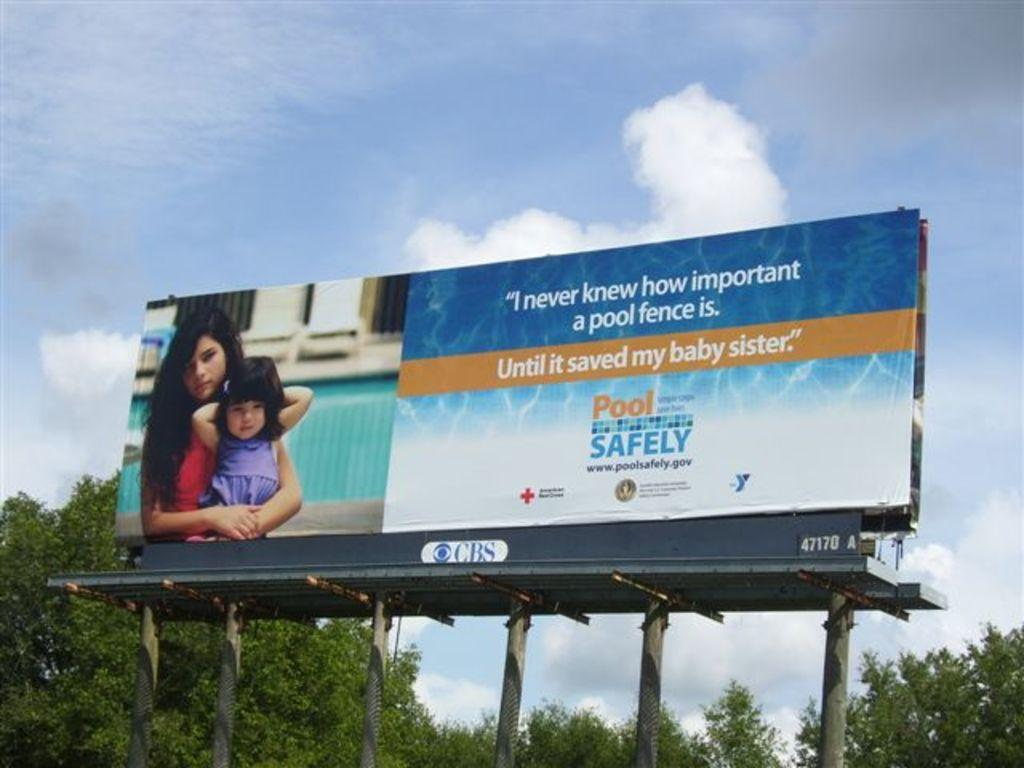<image>
Provide a brief description of the given image. A billboard for Pool Safety with a CBS logo underneath it. 